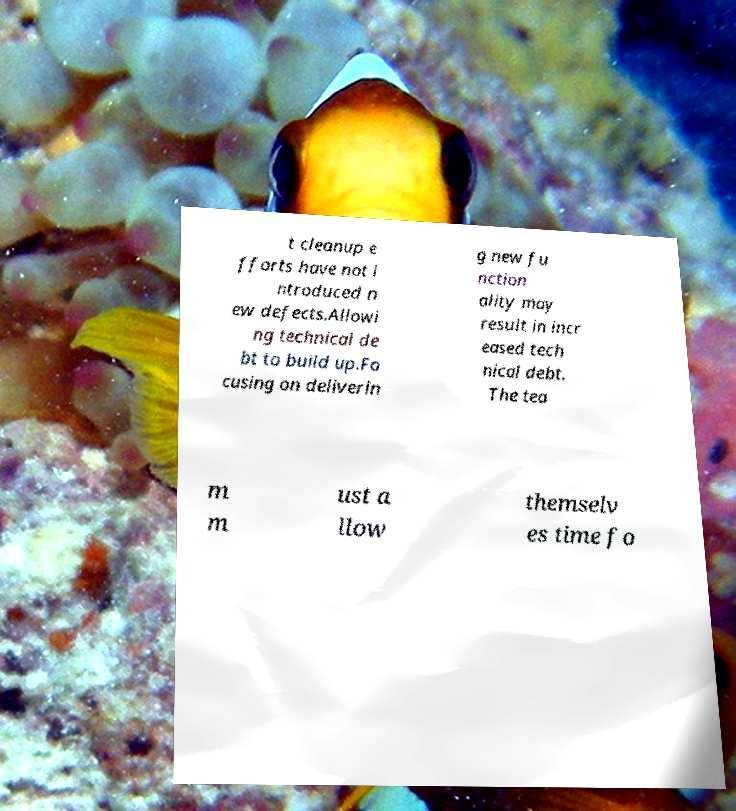Can you accurately transcribe the text from the provided image for me? t cleanup e fforts have not i ntroduced n ew defects.Allowi ng technical de bt to build up.Fo cusing on deliverin g new fu nction ality may result in incr eased tech nical debt. The tea m m ust a llow themselv es time fo 